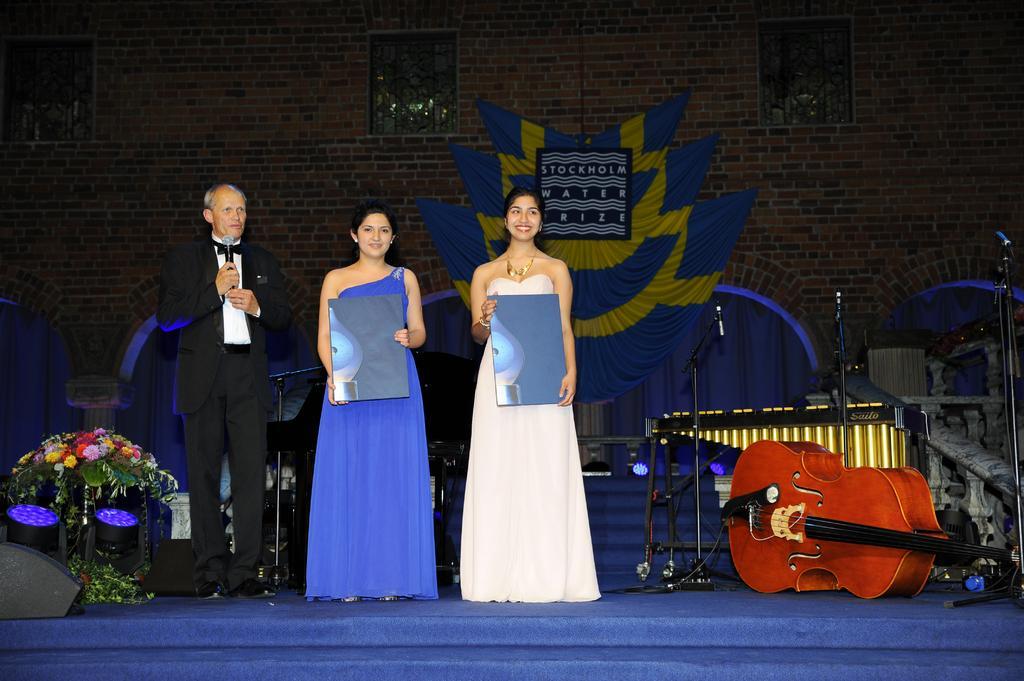How would you summarize this image in a sentence or two? These three persons are standing. This person holding microphone. We can see guitar,microphones with stand,piano. On the background we can see wall,banner. 